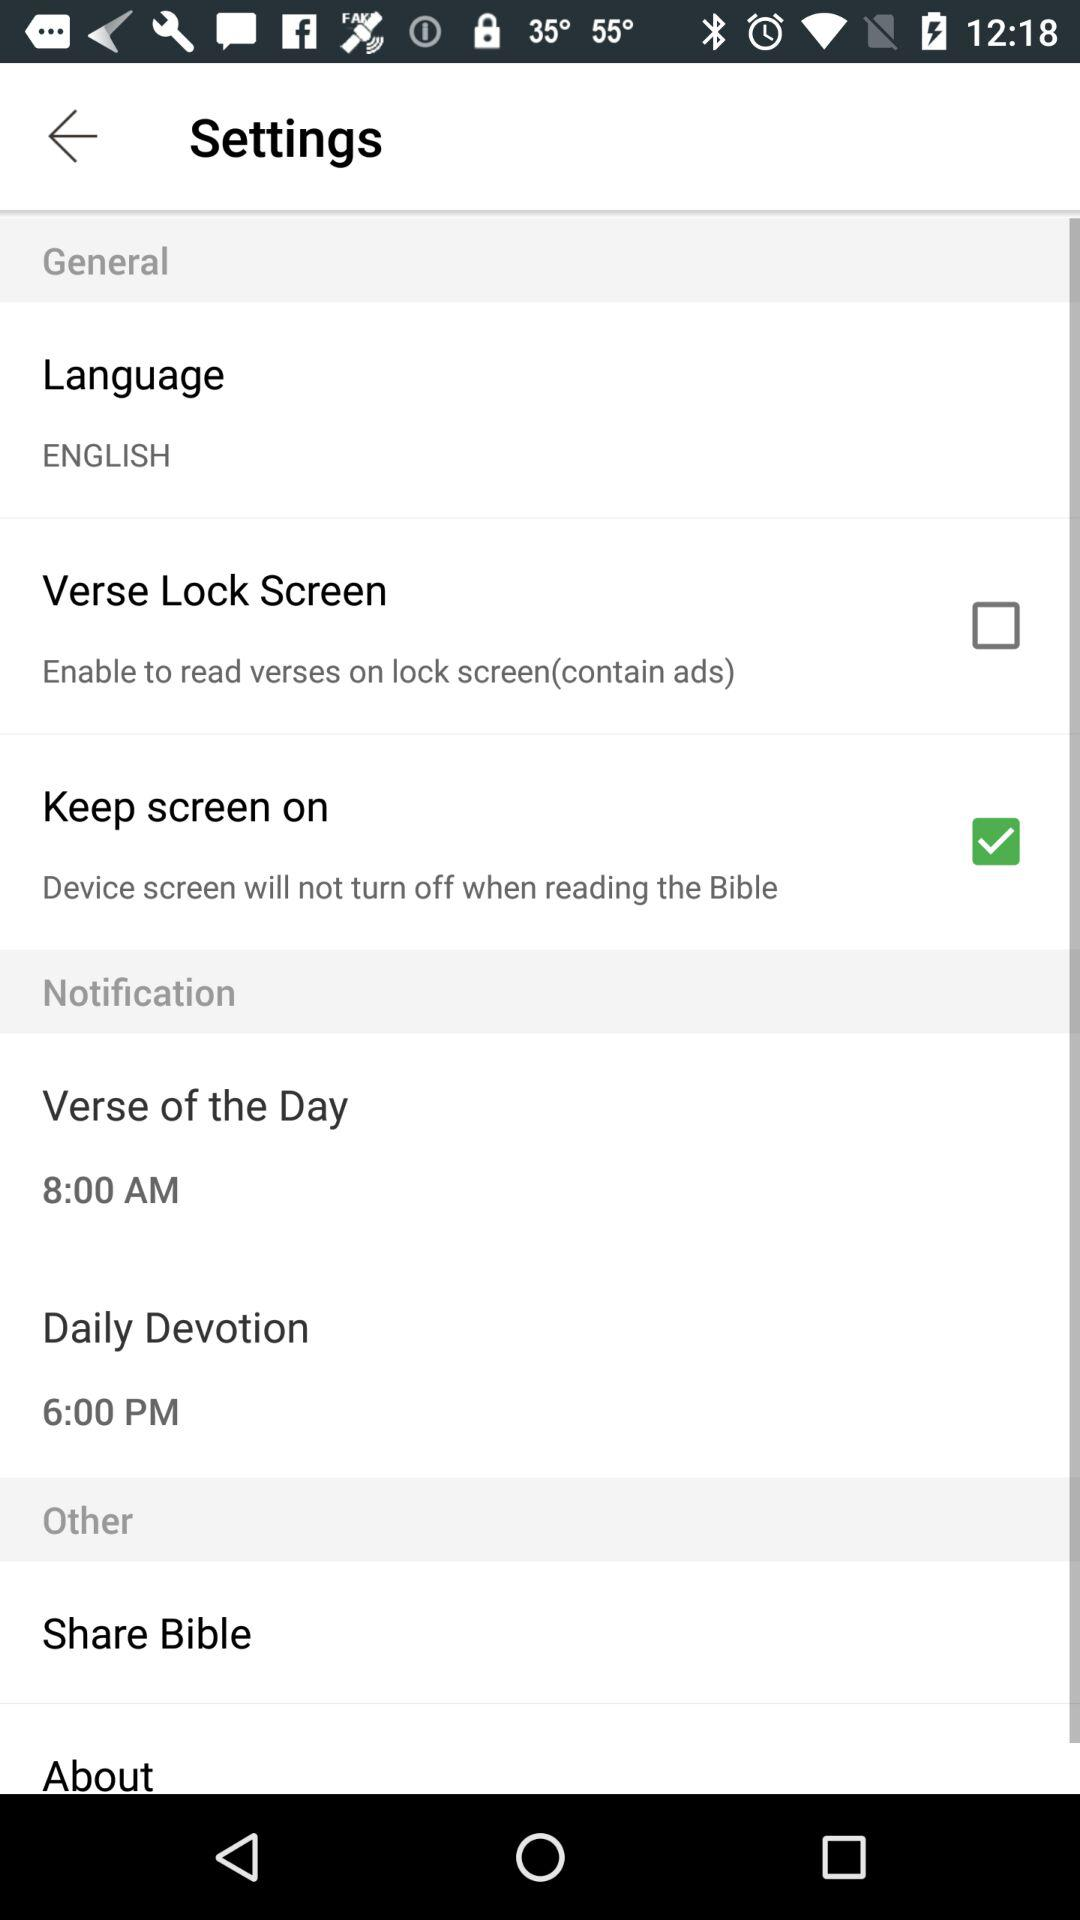What is the time set for daily devotion? The time set for daily devotion is 6:00 PM. 